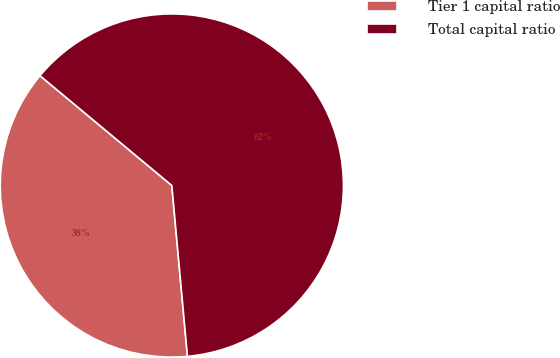<chart> <loc_0><loc_0><loc_500><loc_500><pie_chart><fcel>Tier 1 capital ratio<fcel>Total capital ratio<nl><fcel>37.5%<fcel>62.5%<nl></chart> 